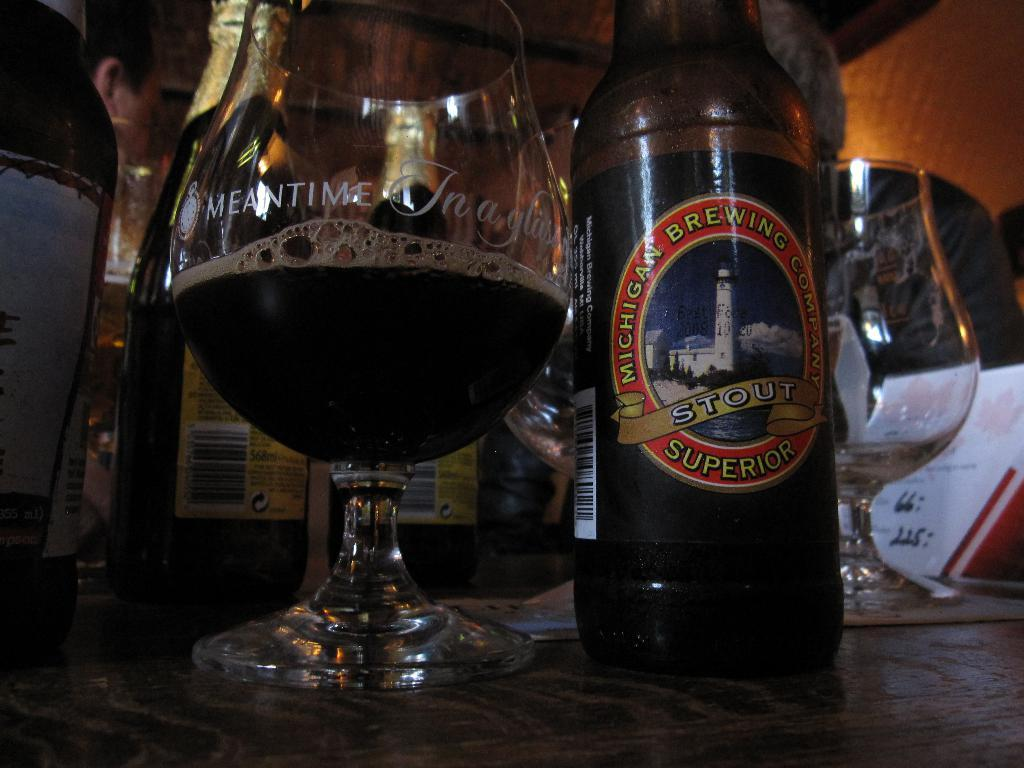What is present in the image that contains a liquid? There is a glass in the image, and it contains a drink. What is written on the bottle in the image? The bottle has the word "superior" written on it. Where are the bottle and glass located in the image? The bottle and glass are placed on a table. What might be used to consume the drink in the glass? The glass itself can be used to consume the drink. What is the reason the boys are exploring the cave in the image? There is no mention of boys or a cave in the image; it only features a bottle and a glass on a table. 